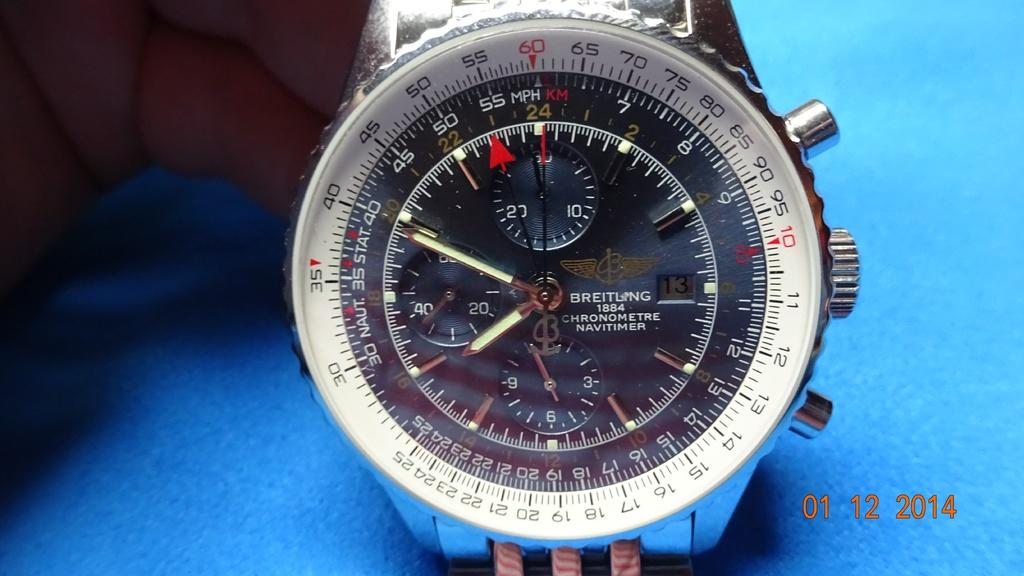<image>
Relay a brief, clear account of the picture shown. A Breitling chronometer watch has glow in the dark hands. 